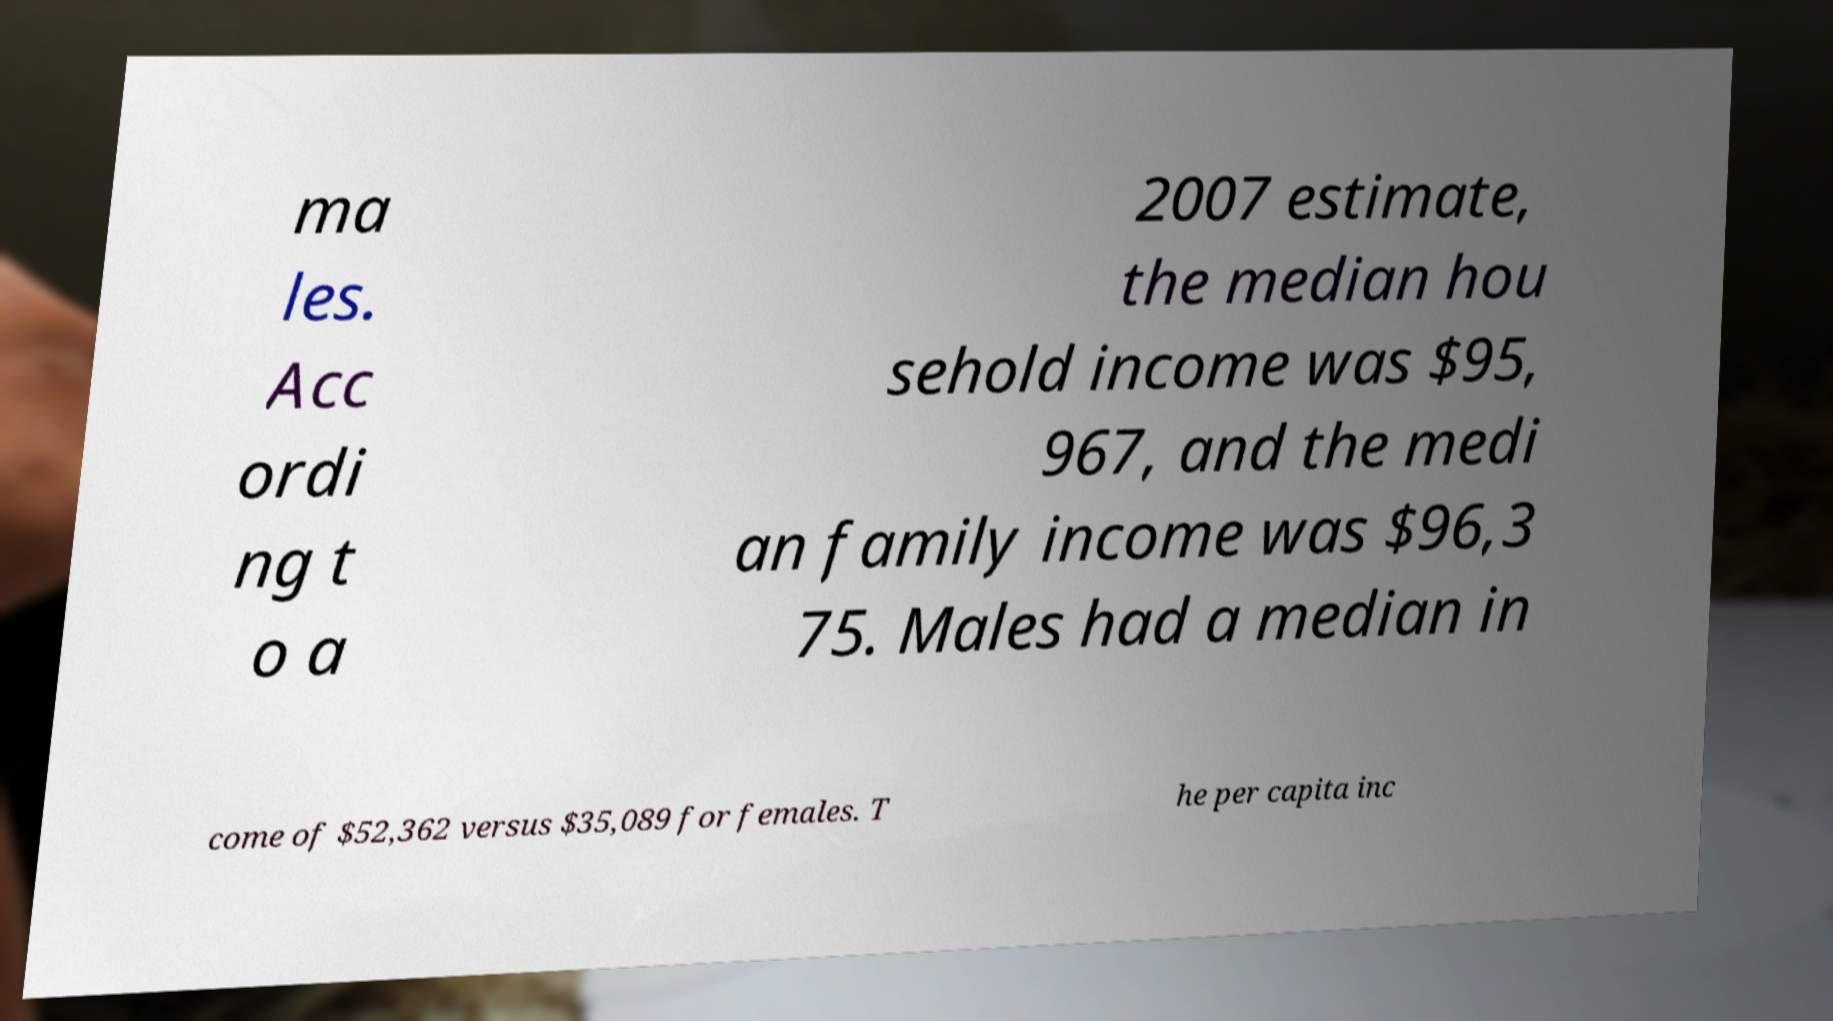For documentation purposes, I need the text within this image transcribed. Could you provide that? ma les. Acc ordi ng t o a 2007 estimate, the median hou sehold income was $95, 967, and the medi an family income was $96,3 75. Males had a median in come of $52,362 versus $35,089 for females. T he per capita inc 